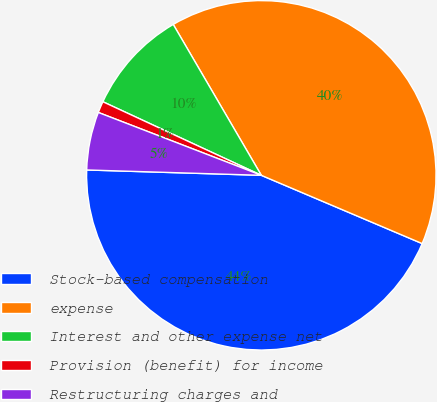Convert chart. <chart><loc_0><loc_0><loc_500><loc_500><pie_chart><fcel>Stock-based compensation<fcel>expense<fcel>Interest and other expense net<fcel>Provision (benefit) for income<fcel>Restructuring charges and<nl><fcel>44.1%<fcel>39.8%<fcel>9.67%<fcel>1.06%<fcel>5.37%<nl></chart> 